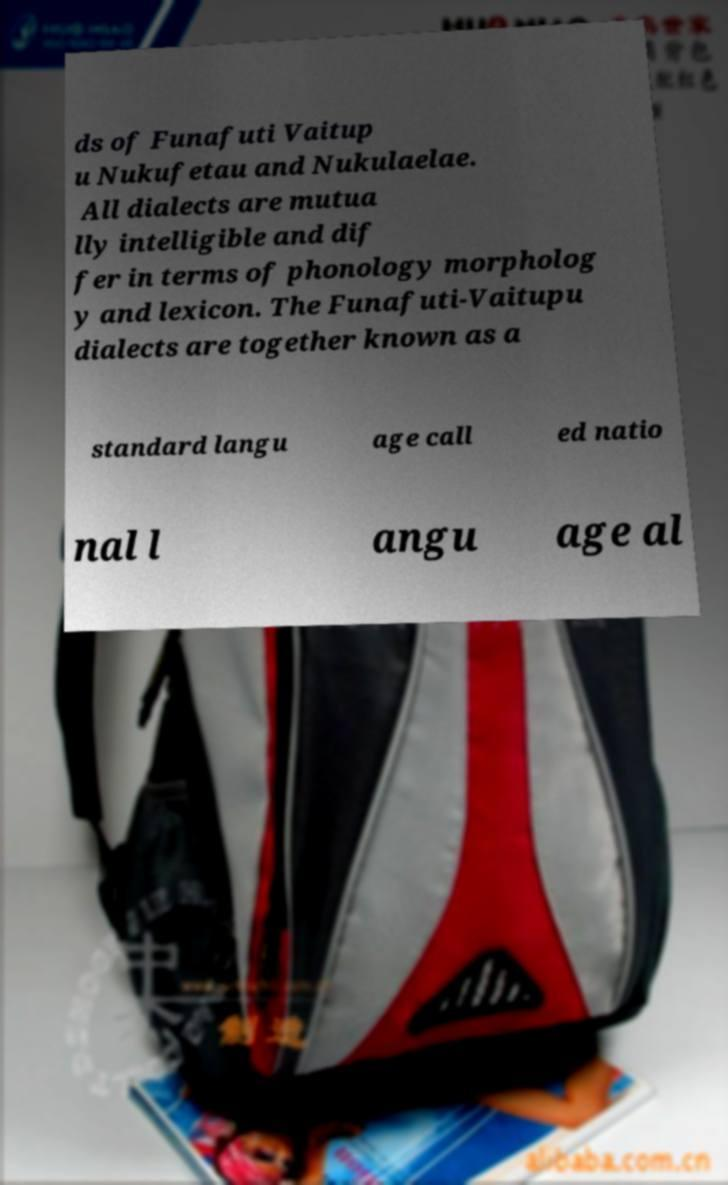Could you extract and type out the text from this image? ds of Funafuti Vaitup u Nukufetau and Nukulaelae. All dialects are mutua lly intelligible and dif fer in terms of phonology morpholog y and lexicon. The Funafuti-Vaitupu dialects are together known as a standard langu age call ed natio nal l angu age al 